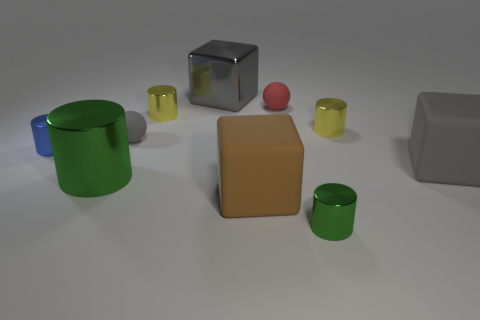Is there a tiny red object that has the same material as the gray ball?
Your response must be concise. Yes. Are there more green objects on the left side of the big gray rubber cube than brown rubber things that are to the right of the tiny red matte sphere?
Provide a succinct answer. Yes. Do the shiny block and the red matte sphere have the same size?
Provide a succinct answer. No. The cylinder that is behind the yellow cylinder right of the tiny green shiny thing is what color?
Your answer should be very brief. Yellow. The large cylinder has what color?
Your response must be concise. Green. Is there a small rubber thing that has the same color as the large metallic cylinder?
Your answer should be very brief. No. There is a tiny metal cylinder in front of the blue cylinder; does it have the same color as the large metallic block?
Provide a succinct answer. No. What number of objects are gray things that are to the right of the gray metallic object or gray matte balls?
Your response must be concise. 2. Are there any tiny yellow shiny objects in front of the large gray rubber cube?
Keep it short and to the point. No. What is the material of the other big cube that is the same color as the large metal cube?
Offer a terse response. Rubber. 